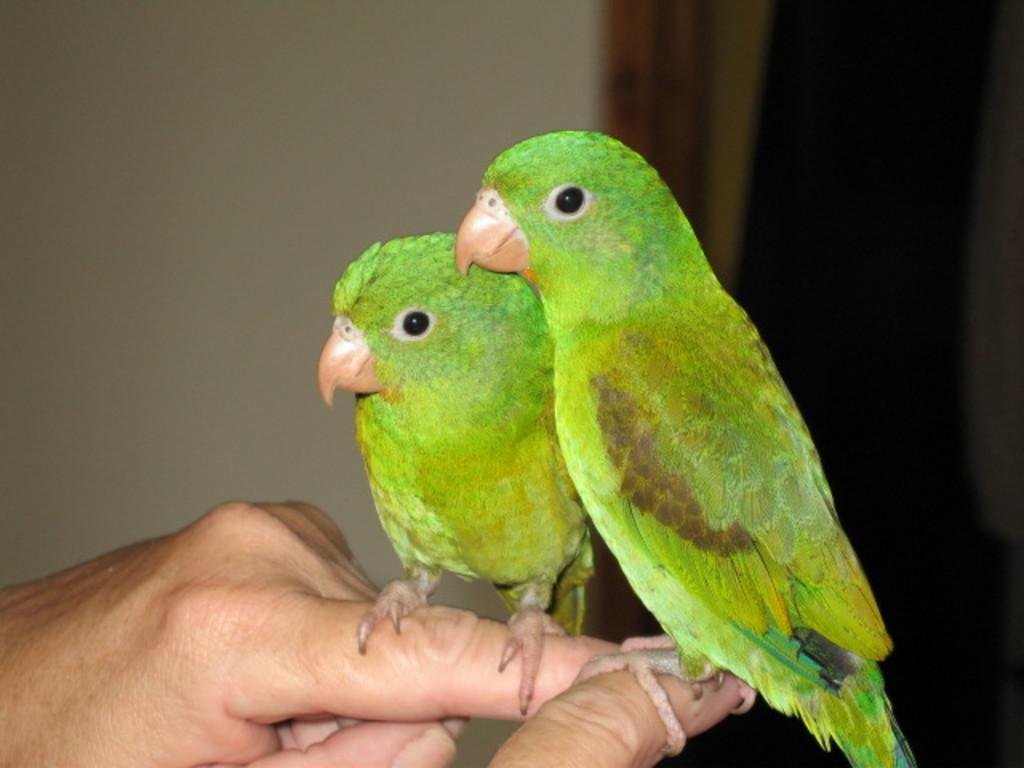How many parrots are in the image? There are two parrots in the image. Where are the parrots located in the image? The parrots are on the fingers of persons. Can you describe the background of the image? The background of the image is blurred. What can be seen in the background of the image? There is a curtain and a wall in the background of the image. What type of machine can be seen in the image? There is no machine present in the image; it features two parrots on the fingers of persons. How many stars are visible in the image? There are no stars visible in the image. 